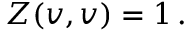Convert formula to latex. <formula><loc_0><loc_0><loc_500><loc_500>Z ( v , v ) = 1 \, .</formula> 